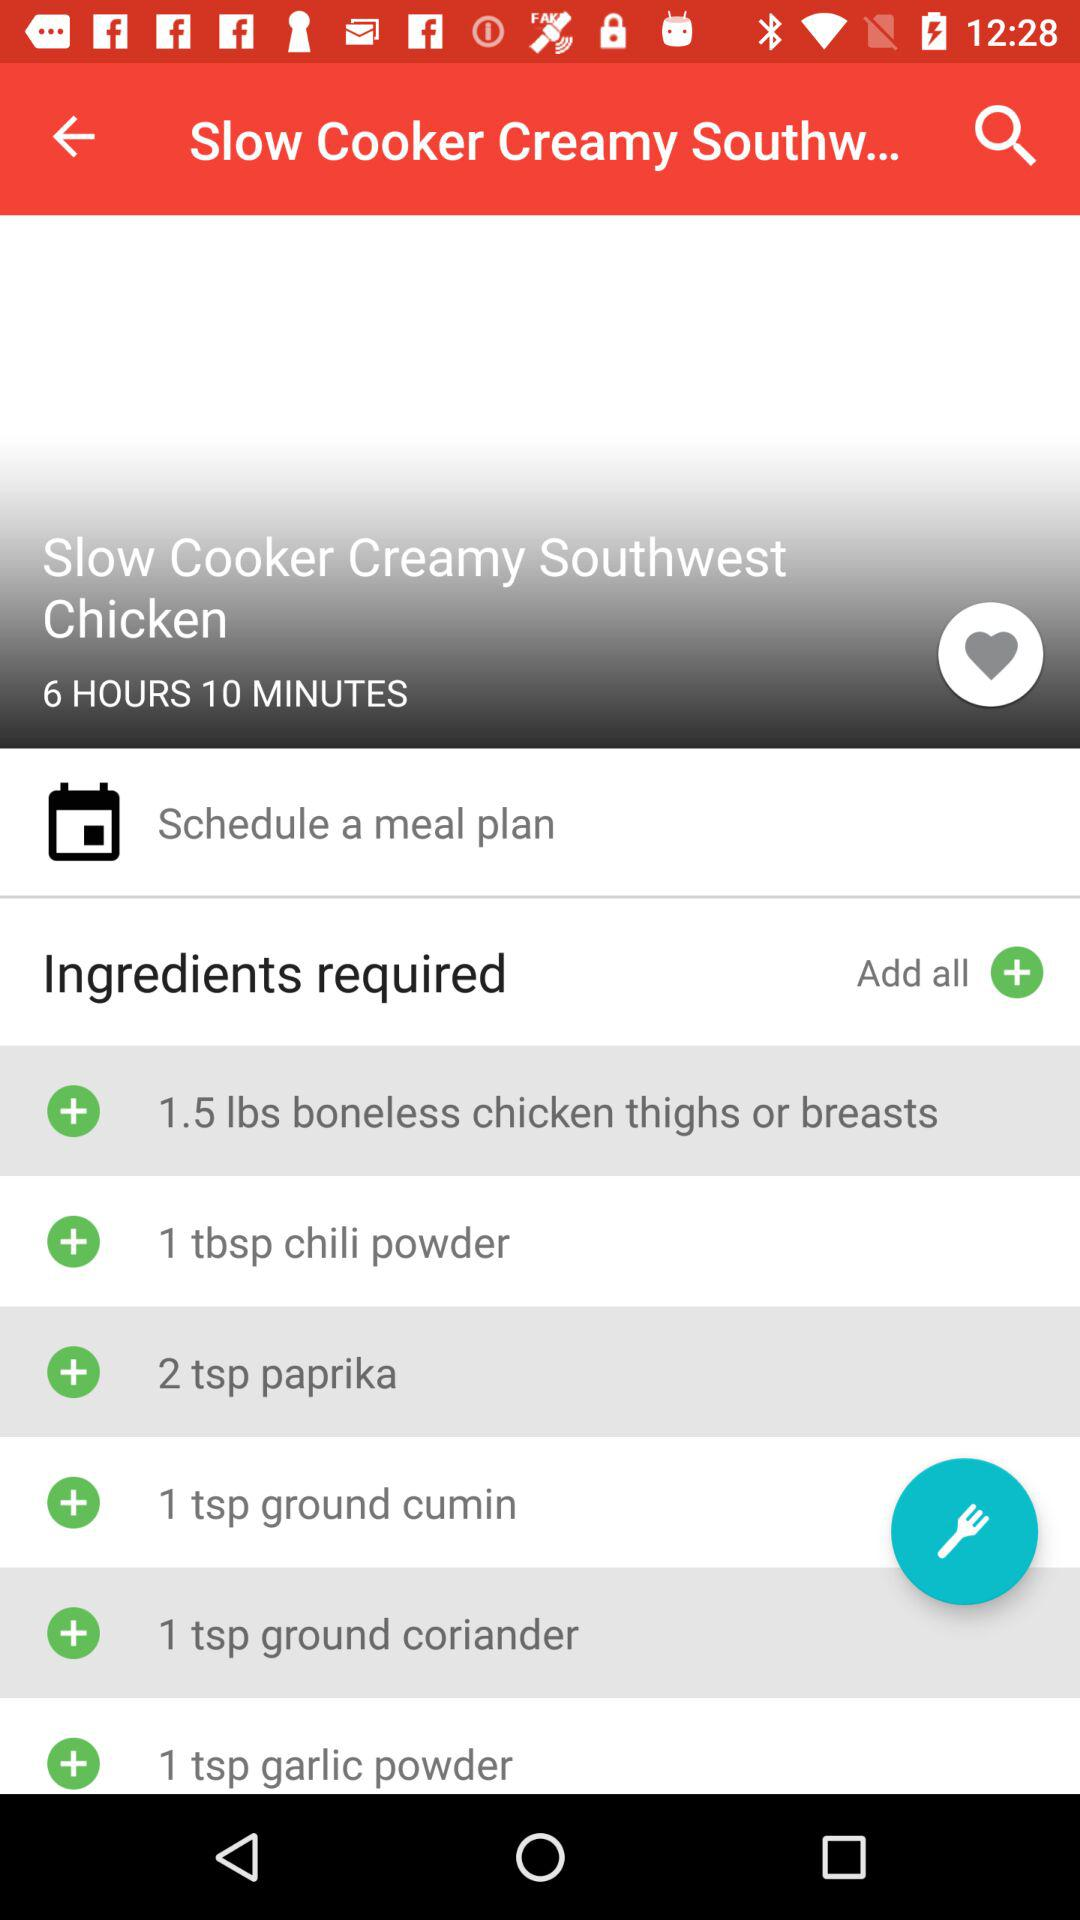How many spoons of paprika are required? There are 2 teaspoons of paprika required. 